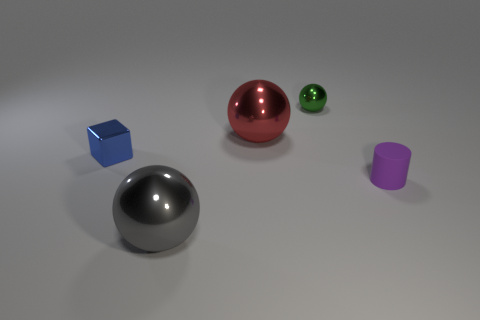There is another tiny thing that is the same shape as the gray metal thing; what is it made of?
Your answer should be very brief. Metal. How many green metal balls have the same size as the gray metal sphere?
Provide a short and direct response. 0. What number of tiny green metal cubes are there?
Give a very brief answer. 0. Is the tiny purple cylinder made of the same material as the big thing on the right side of the big gray sphere?
Your answer should be compact. No. What number of red things are either rubber cylinders or big rubber things?
Keep it short and to the point. 0. The cube that is the same material as the big gray ball is what size?
Offer a very short reply. Small. What number of other rubber things have the same shape as the small purple rubber object?
Offer a terse response. 0. Is the number of large shiny spheres in front of the tiny purple matte cylinder greater than the number of tiny blue cubes that are to the right of the gray shiny thing?
Provide a succinct answer. Yes. There is a gray thing that is the same size as the red metal sphere; what is its material?
Make the answer very short. Metal. How many things are either tiny yellow shiny blocks or small objects that are behind the cube?
Offer a very short reply. 1. 